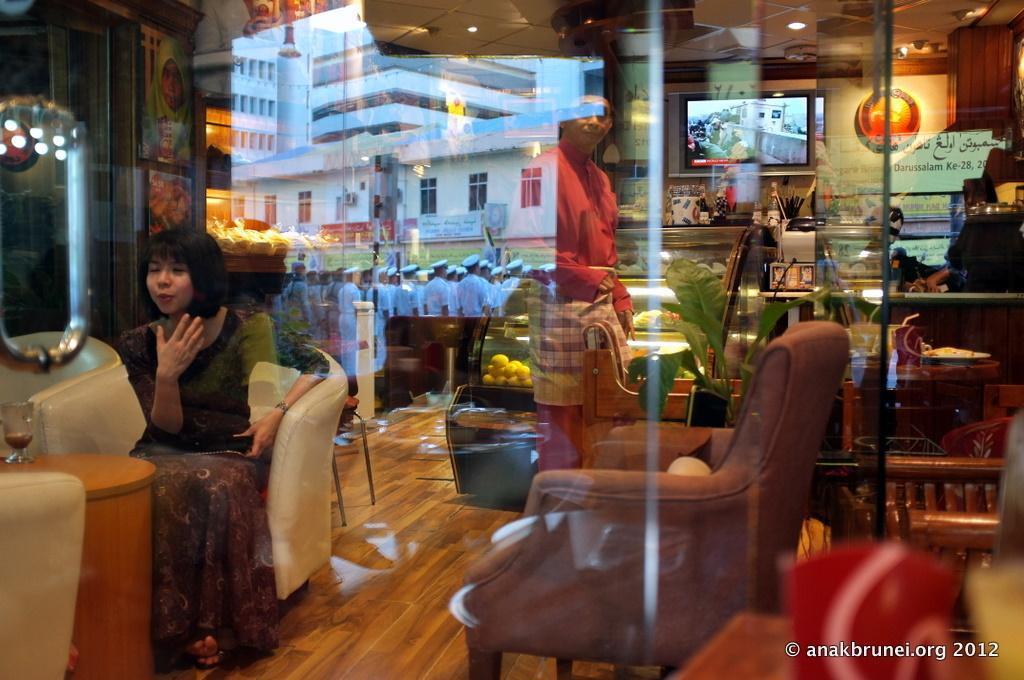Please provide a concise description of this image. This picture shows a woman sitting in the sofa in front of a table. There is a empty sofa here. In the background, there is man standing and some soldiers assembled here. We can observe a television and some food items placed in the desk here. 